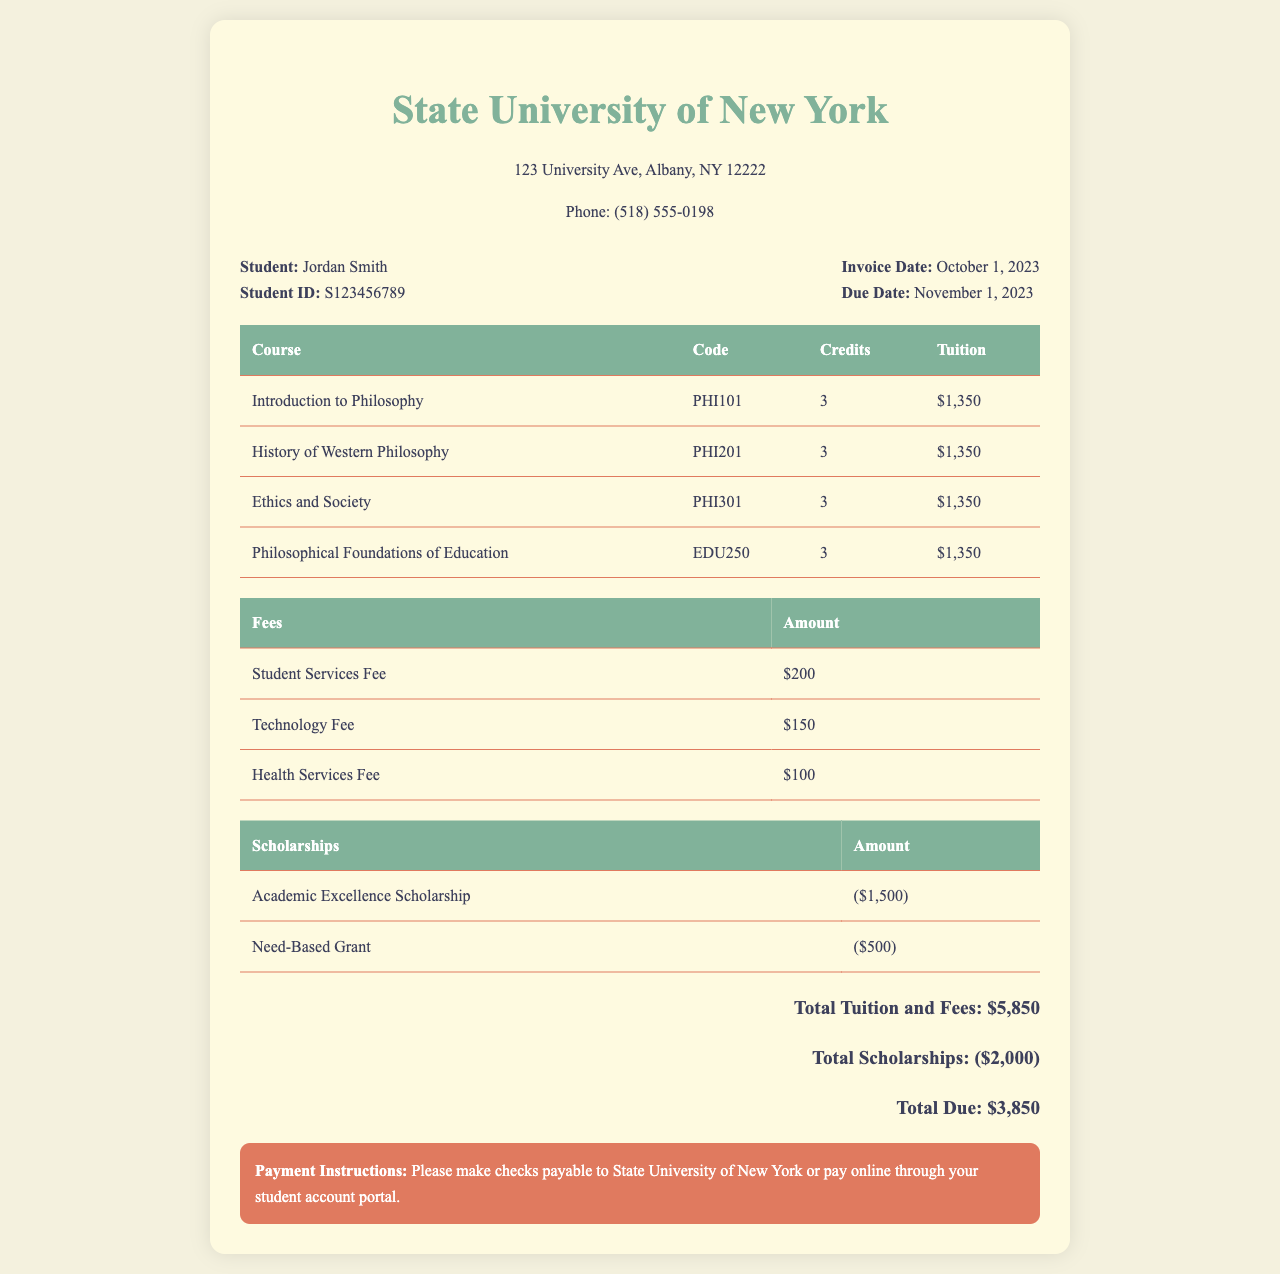What is the student's name? The student's name is mentioned in the student info section.
Answer: Jordan Smith What is the total tuition and fees? The total tuition and fees are calculated and displayed at the bottom of the invoice.
Answer: $5,850 What is the due date for the invoice? The due date is specified in the student info section.
Answer: November 1, 2023 How many courses are listed in the invoice? The number of courses can be counted from the course table in the document.
Answer: 4 What amount is deducted for scholarships? The total amount deducted for scholarships is shown in the scholarship table.
Answer: ($2,000) What is the fee for health services? The health services fee is specified in the fees table.
Answer: $100 What is the total due? The total due is calculated from the total tuition and fees after scholarship deductions.
Answer: $3,850 What is the code for the Introduction to Philosophy course? The course code is found in the course table next to its title.
Answer: PHI101 What are the payment instructions? The payment instructions are provided at the bottom of the invoice.
Answer: Please make checks payable to State University of New York or pay online through your student account portal 